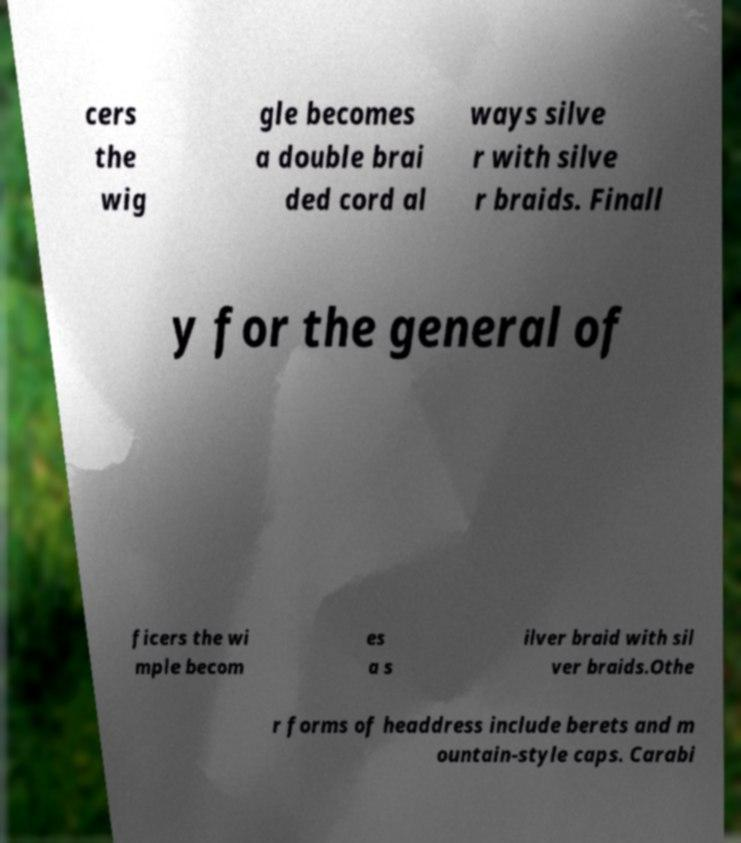Can you accurately transcribe the text from the provided image for me? cers the wig gle becomes a double brai ded cord al ways silve r with silve r braids. Finall y for the general of ficers the wi mple becom es a s ilver braid with sil ver braids.Othe r forms of headdress include berets and m ountain-style caps. Carabi 